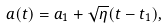Convert formula to latex. <formula><loc_0><loc_0><loc_500><loc_500>a ( t ) = a _ { 1 } + \sqrt { \eta } ( t - t _ { 1 } ) ,</formula> 